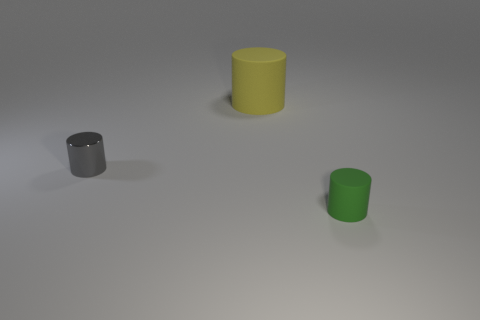Add 2 shiny things. How many objects exist? 5 Add 2 tiny matte cylinders. How many tiny matte cylinders are left? 3 Add 2 red metallic cubes. How many red metallic cubes exist? 2 Subtract 0 blue cylinders. How many objects are left? 3 Subtract all big red cubes. Subtract all tiny shiny cylinders. How many objects are left? 2 